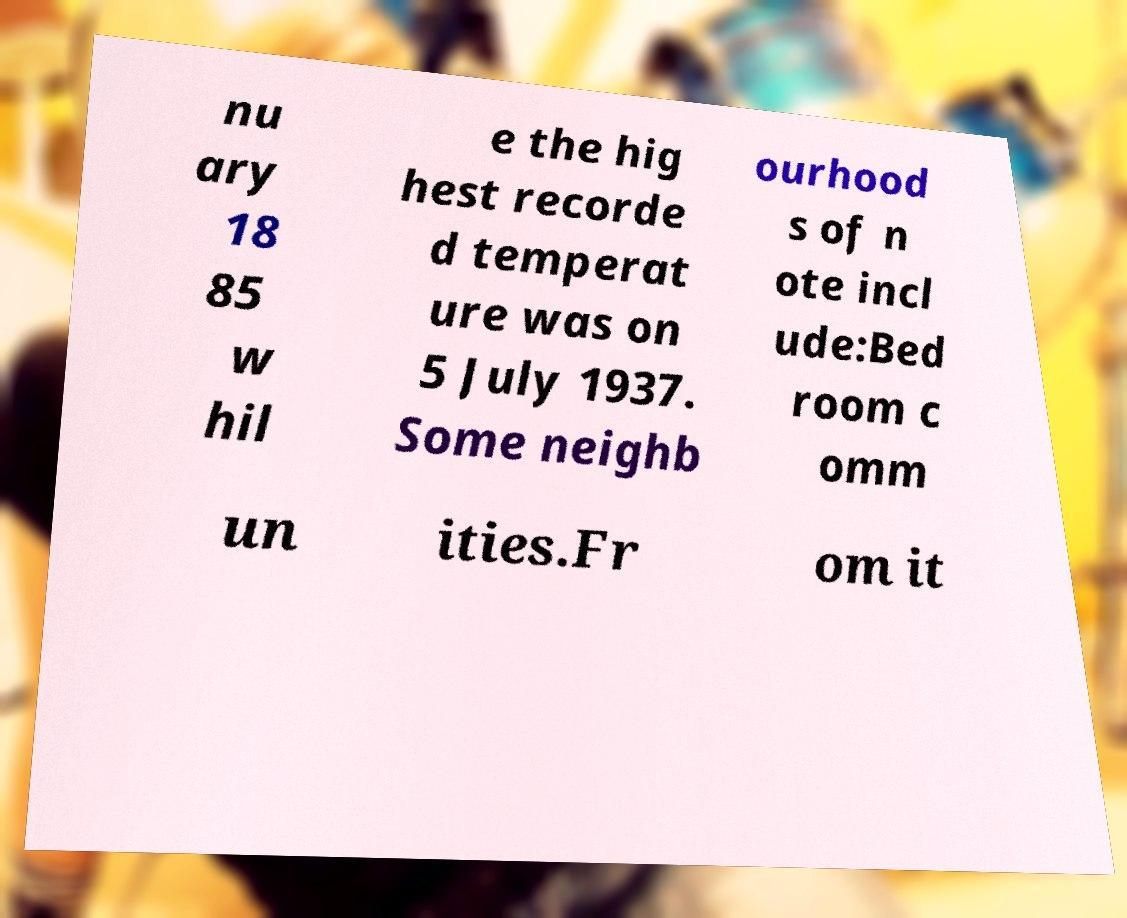Can you read and provide the text displayed in the image?This photo seems to have some interesting text. Can you extract and type it out for me? nu ary 18 85 w hil e the hig hest recorde d temperat ure was on 5 July 1937. Some neighb ourhood s of n ote incl ude:Bed room c omm un ities.Fr om it 